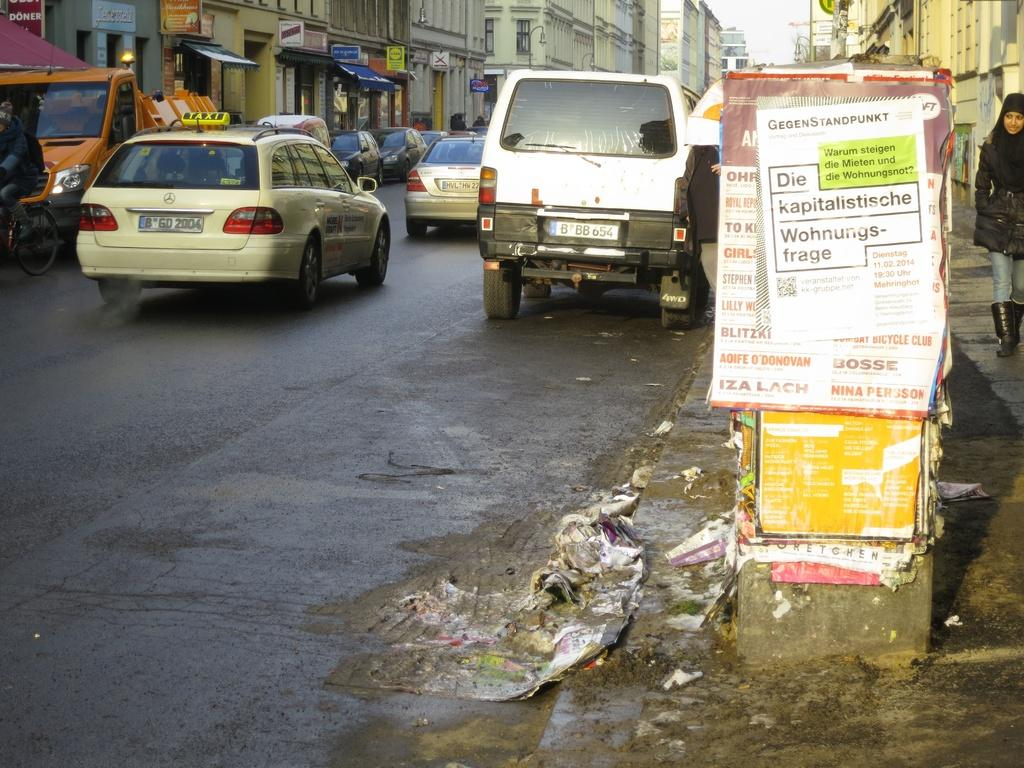<image>
Share a concise interpretation of the image provided. A busy street has a sign that says Die kapitalistische Wohnungs-frage. 